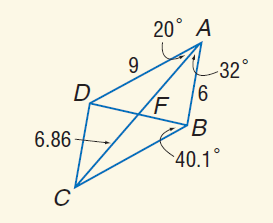Answer the mathemtical geometry problem and directly provide the correct option letter.
Question: Use parallelogram A B C D to find A F.
Choices: A: 6 B: 6.86 C: 9 D: 13.62 B 